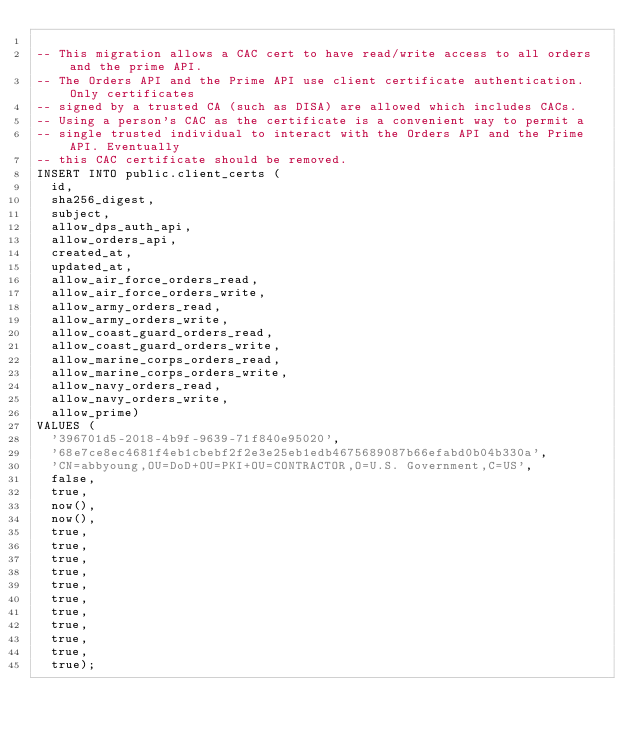Convert code to text. <code><loc_0><loc_0><loc_500><loc_500><_SQL_>
-- This migration allows a CAC cert to have read/write access to all orders and the prime API.
-- The Orders API and the Prime API use client certificate authentication. Only certificates
-- signed by a trusted CA (such as DISA) are allowed which includes CACs.
-- Using a person's CAC as the certificate is a convenient way to permit a
-- single trusted individual to interact with the Orders API and the Prime API. Eventually
-- this CAC certificate should be removed.
INSERT INTO public.client_certs (
	id,
	sha256_digest,
	subject,
	allow_dps_auth_api,
	allow_orders_api,
	created_at,
	updated_at,
	allow_air_force_orders_read,
	allow_air_force_orders_write,
	allow_army_orders_read,
	allow_army_orders_write,
	allow_coast_guard_orders_read,
	allow_coast_guard_orders_write,
	allow_marine_corps_orders_read,
	allow_marine_corps_orders_write,
	allow_navy_orders_read,
	allow_navy_orders_write,
	allow_prime)
VALUES (
	'396701d5-2018-4b9f-9639-71f840e95020',
	'68e7ce8ec4681f4eb1cbebf2f2e3e25eb1edb4675689087b66efabd0b04b330a',
	'CN=abbyoung,OU=DoD+OU=PKI+OU=CONTRACTOR,O=U.S. Government,C=US',
	false,
	true,
	now(),
	now(),
	true,
	true,
	true,
	true,
	true,
	true,
	true,
	true,
	true,
	true,
	true);
</code> 